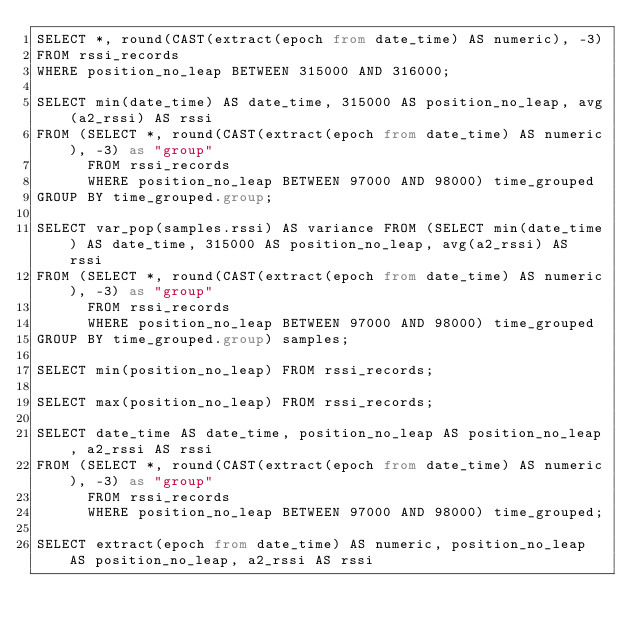<code> <loc_0><loc_0><loc_500><loc_500><_SQL_>SELECT *, round(CAST(extract(epoch from date_time) AS numeric), -3)
FROM rssi_records
WHERE position_no_leap BETWEEN 315000 AND 316000;

SELECT min(date_time) AS date_time, 315000 AS position_no_leap, avg(a2_rssi) AS rssi
FROM (SELECT *, round(CAST(extract(epoch from date_time) AS numeric), -3) as "group"
      FROM rssi_records
      WHERE position_no_leap BETWEEN 97000 AND 98000) time_grouped
GROUP BY time_grouped.group;

SELECT var_pop(samples.rssi) AS variance FROM (SELECT min(date_time) AS date_time, 315000 AS position_no_leap, avg(a2_rssi) AS rssi
FROM (SELECT *, round(CAST(extract(epoch from date_time) AS numeric), -3) as "group"
      FROM rssi_records
      WHERE position_no_leap BETWEEN 97000 AND 98000) time_grouped
GROUP BY time_grouped.group) samples;

SELECT min(position_no_leap) FROM rssi_records;

SELECT max(position_no_leap) FROM rssi_records;

SELECT date_time AS date_time, position_no_leap AS position_no_leap, a2_rssi AS rssi
FROM (SELECT *, round(CAST(extract(epoch from date_time) AS numeric), -3) as "group"
      FROM rssi_records
      WHERE position_no_leap BETWEEN 97000 AND 98000) time_grouped;

SELECT extract(epoch from date_time) AS numeric, position_no_leap AS position_no_leap, a2_rssi AS rssi</code> 